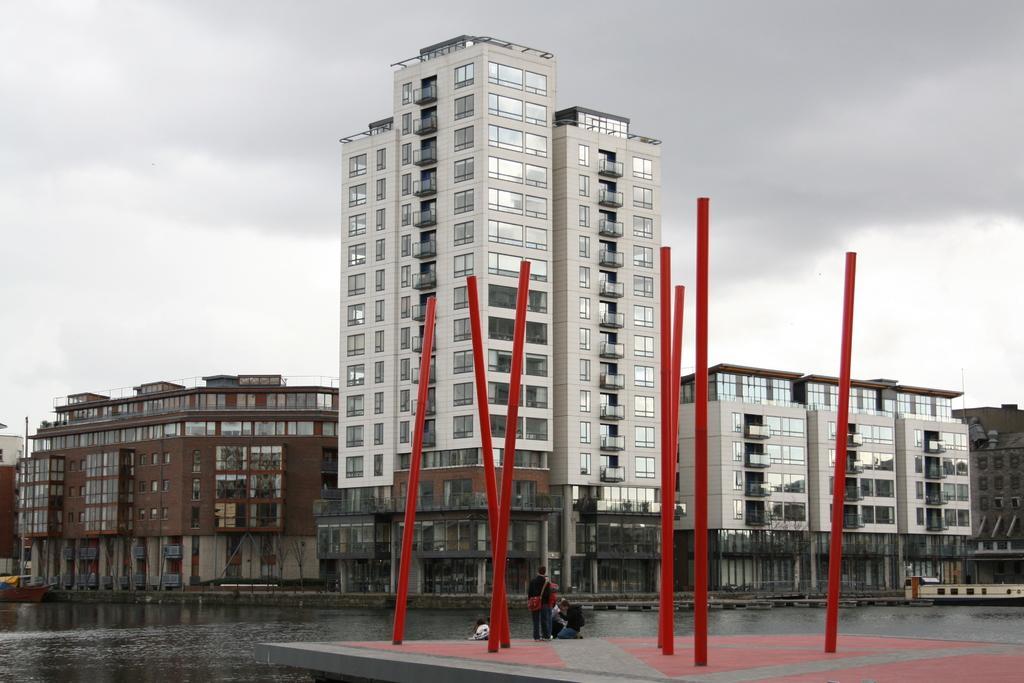Could you give a brief overview of what you see in this image? In the background of the image there are buildings. At the bottom of the image there is water. In the center of the image there are red color pipes. There are people standing. At the top of the image there are clouds. 